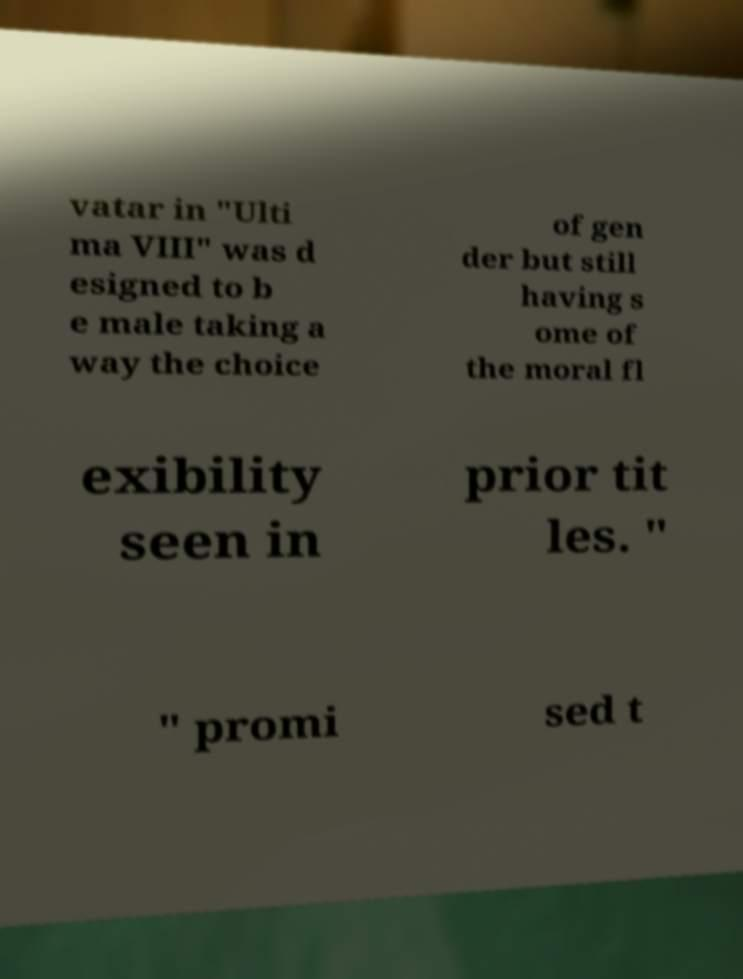Can you read and provide the text displayed in the image?This photo seems to have some interesting text. Can you extract and type it out for me? vatar in "Ulti ma VIII" was d esigned to b e male taking a way the choice of gen der but still having s ome of the moral fl exibility seen in prior tit les. " " promi sed t 